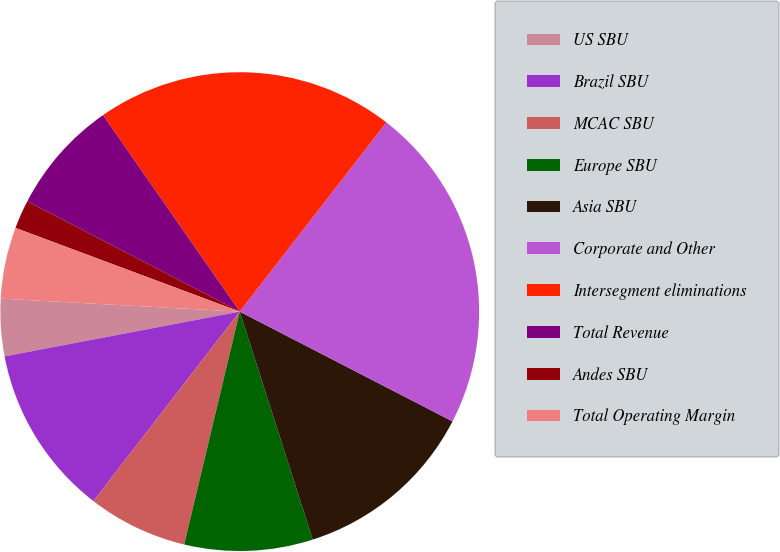Convert chart to OTSL. <chart><loc_0><loc_0><loc_500><loc_500><pie_chart><fcel>US SBU<fcel>Brazil SBU<fcel>MCAC SBU<fcel>Europe SBU<fcel>Asia SBU<fcel>Corporate and Other<fcel>Intersegment eliminations<fcel>Total Revenue<fcel>Andes SBU<fcel>Total Operating Margin<nl><fcel>3.86%<fcel>11.54%<fcel>6.74%<fcel>8.66%<fcel>12.49%<fcel>22.09%<fcel>20.17%<fcel>7.7%<fcel>1.94%<fcel>4.82%<nl></chart> 